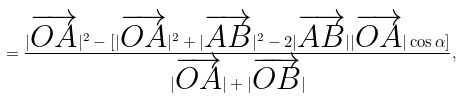Convert formula to latex. <formula><loc_0><loc_0><loc_500><loc_500>= \frac { | \overrightarrow { O A } | ^ { 2 } - [ | \overrightarrow { O A } | ^ { 2 } + | \overrightarrow { A B } | ^ { 2 } - 2 | \overrightarrow { A B } | | \overrightarrow { O A } | \cos { \alpha } ] } { | \overrightarrow { O A } | + | \overrightarrow { O B } | } ,</formula> 